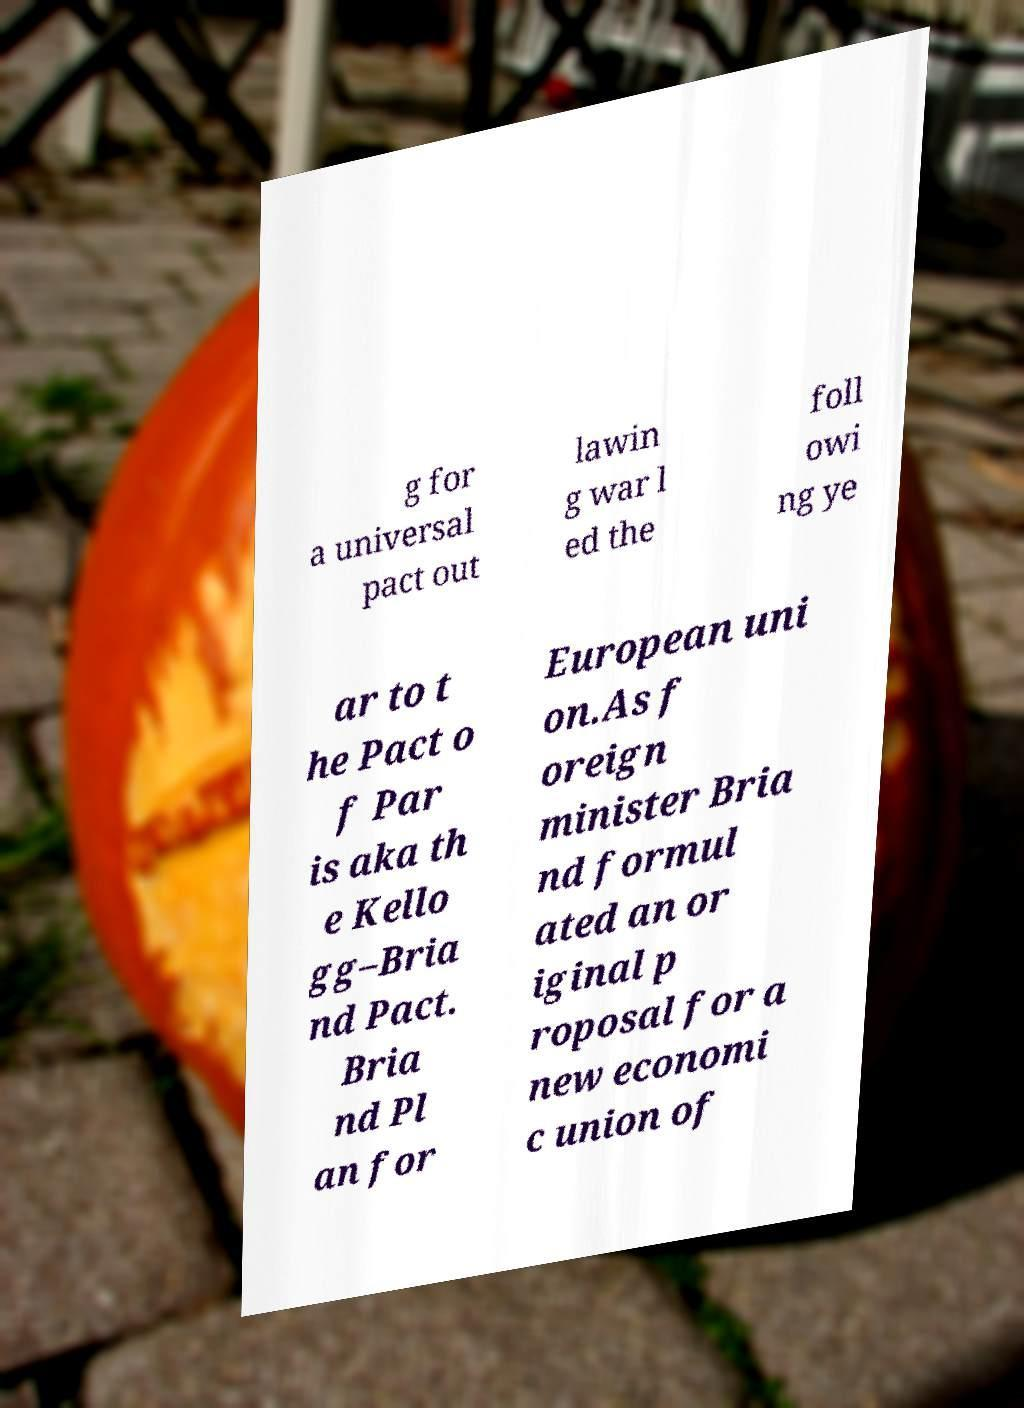Could you assist in decoding the text presented in this image and type it out clearly? g for a universal pact out lawin g war l ed the foll owi ng ye ar to t he Pact o f Par is aka th e Kello gg–Bria nd Pact. Bria nd Pl an for European uni on.As f oreign minister Bria nd formul ated an or iginal p roposal for a new economi c union of 